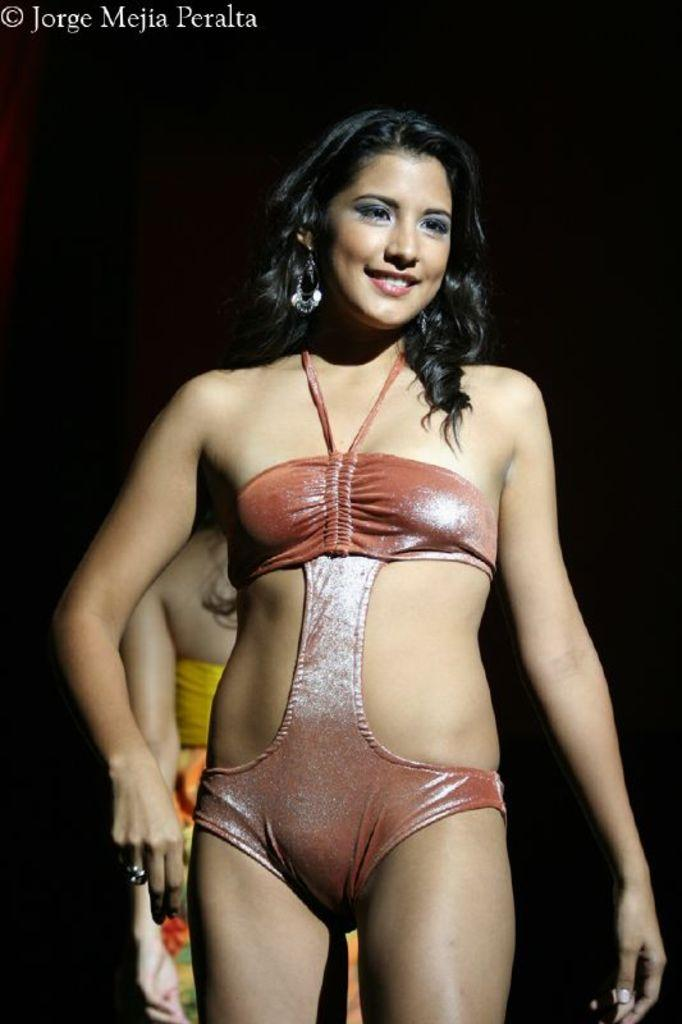What is the main subject of the image? There is a woman standing in the image. How does the woman appear to be feeling? The woman has a smile on her face, indicating a positive emotion. Can you describe the presence of another person in the image? There is another woman visible in the background of the image. What is located at the top of the image? There is text at the top of the image. What type of farm animals can be seen in the image? There are no farm animals present in the image. What role does the queen play in the image? There is no queen present in the image. 